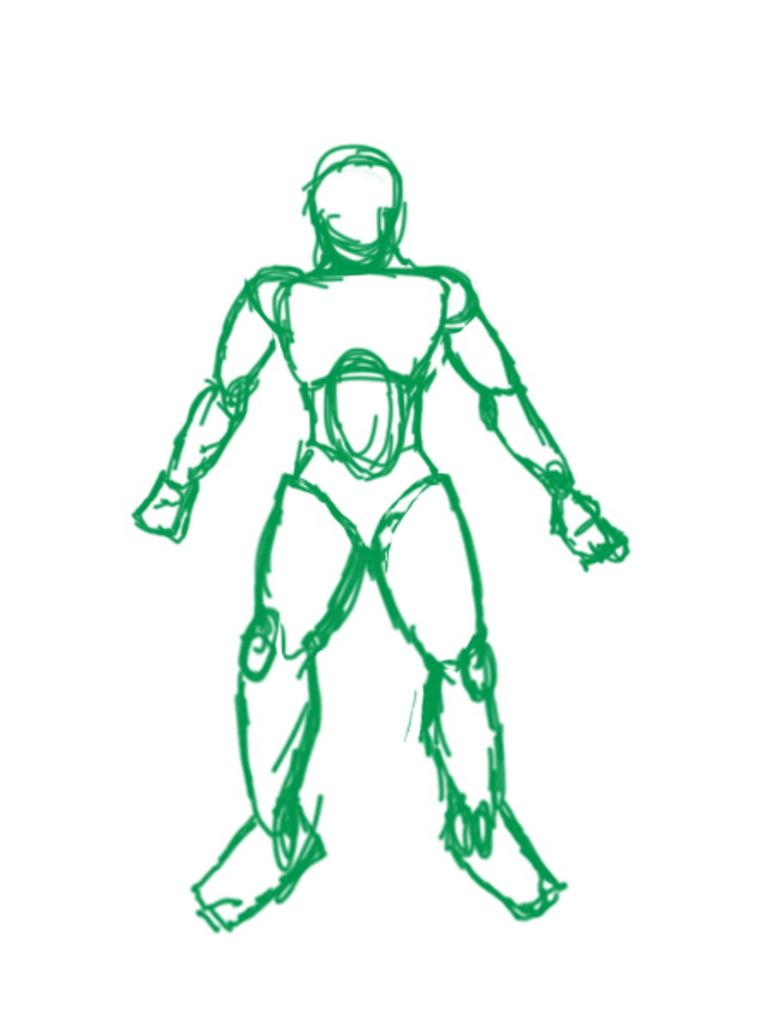What is depicted in the image? There is a drawing in the image. What color is the drawing? The drawing is in green color. What character does the drawing resemble? The drawing resembles Iron Man. What type of lock can be seen in the image? There is no lock present in the image; it features a drawing of Iron Man. How does the drawing shake hands with someone in the image? The drawing does not shake hands with anyone in the image, as it is a static drawing of Iron Man. 